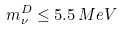Convert formula to latex. <formula><loc_0><loc_0><loc_500><loc_500>m ^ { D } _ { \nu } \leq 5 . 5 \, M e V</formula> 